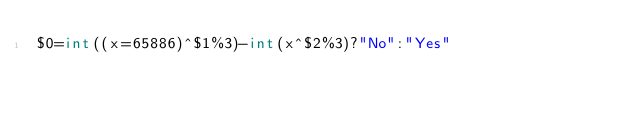<code> <loc_0><loc_0><loc_500><loc_500><_Awk_>$0=int((x=65886)^$1%3)-int(x^$2%3)?"No":"Yes"</code> 